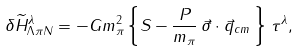<formula> <loc_0><loc_0><loc_500><loc_500>\delta \widetilde { H } _ { \Lambda \pi N } ^ { \lambda } = - G m _ { \pi } ^ { 2 } \left \{ S - \frac { P } { m _ { \pi } } \, \vec { \sigma } \cdot \vec { q } _ { c m } \, \right \} \, \tau ^ { \lambda } ,</formula> 